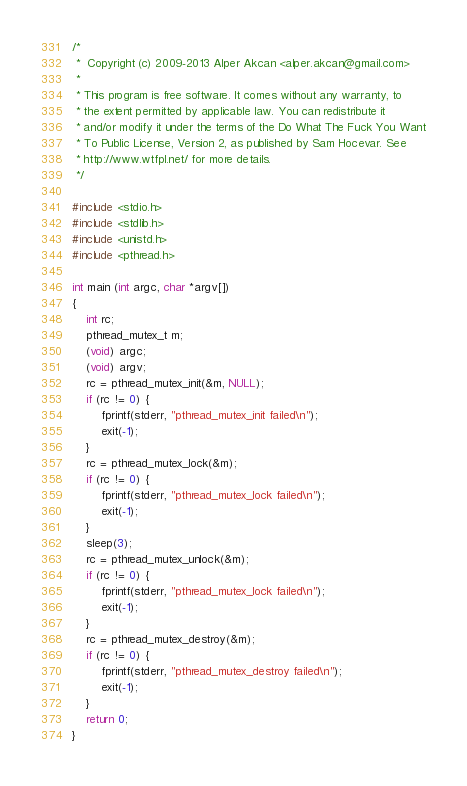<code> <loc_0><loc_0><loc_500><loc_500><_C_>/*
 *  Copyright (c) 2009-2013 Alper Akcan <alper.akcan@gmail.com>
 *
 * This program is free software. It comes without any warranty, to
 * the extent permitted by applicable law. You can redistribute it
 * and/or modify it under the terms of the Do What The Fuck You Want
 * To Public License, Version 2, as published by Sam Hocevar. See
 * http://www.wtfpl.net/ for more details.
 */

#include <stdio.h>
#include <stdlib.h>
#include <unistd.h>
#include <pthread.h>

int main (int argc, char *argv[])
{
	int rc;
	pthread_mutex_t m;
	(void) argc;
	(void) argv;
	rc = pthread_mutex_init(&m, NULL);
	if (rc != 0) {
		fprintf(stderr, "pthread_mutex_init failed\n");
		exit(-1);
	}
	rc = pthread_mutex_lock(&m);
	if (rc != 0) {
		fprintf(stderr, "pthread_mutex_lock failed\n");
		exit(-1);
	}
	sleep(3);
	rc = pthread_mutex_unlock(&m);
	if (rc != 0) {
		fprintf(stderr, "pthread_mutex_lock failed\n");
		exit(-1);
	}
	rc = pthread_mutex_destroy(&m);
	if (rc != 0) {
		fprintf(stderr, "pthread_mutex_destroy failed\n");
		exit(-1);
	}
	return 0;
}
</code> 